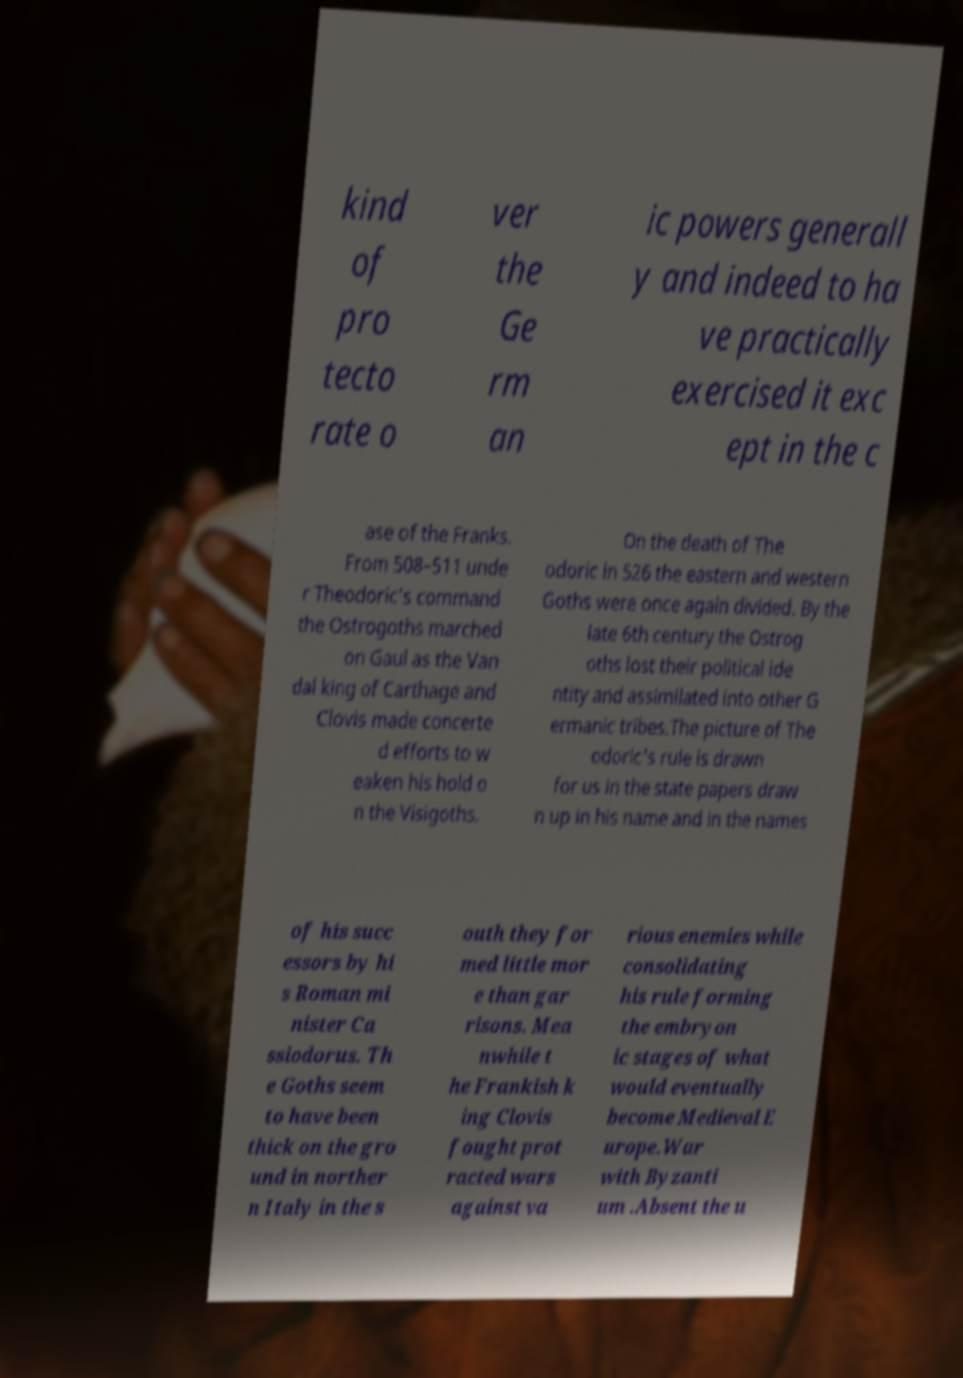Please read and relay the text visible in this image. What does it say? kind of pro tecto rate o ver the Ge rm an ic powers generall y and indeed to ha ve practically exercised it exc ept in the c ase of the Franks. From 508–511 unde r Theodoric's command the Ostrogoths marched on Gaul as the Van dal king of Carthage and Clovis made concerte d efforts to w eaken his hold o n the Visigoths. On the death of The odoric in 526 the eastern and western Goths were once again divided. By the late 6th century the Ostrog oths lost their political ide ntity and assimilated into other G ermanic tribes.The picture of The odoric's rule is drawn for us in the state papers draw n up in his name and in the names of his succ essors by hi s Roman mi nister Ca ssiodorus. Th e Goths seem to have been thick on the gro und in norther n Italy in the s outh they for med little mor e than gar risons. Mea nwhile t he Frankish k ing Clovis fought prot racted wars against va rious enemies while consolidating his rule forming the embryon ic stages of what would eventually become Medieval E urope.War with Byzanti um .Absent the u 